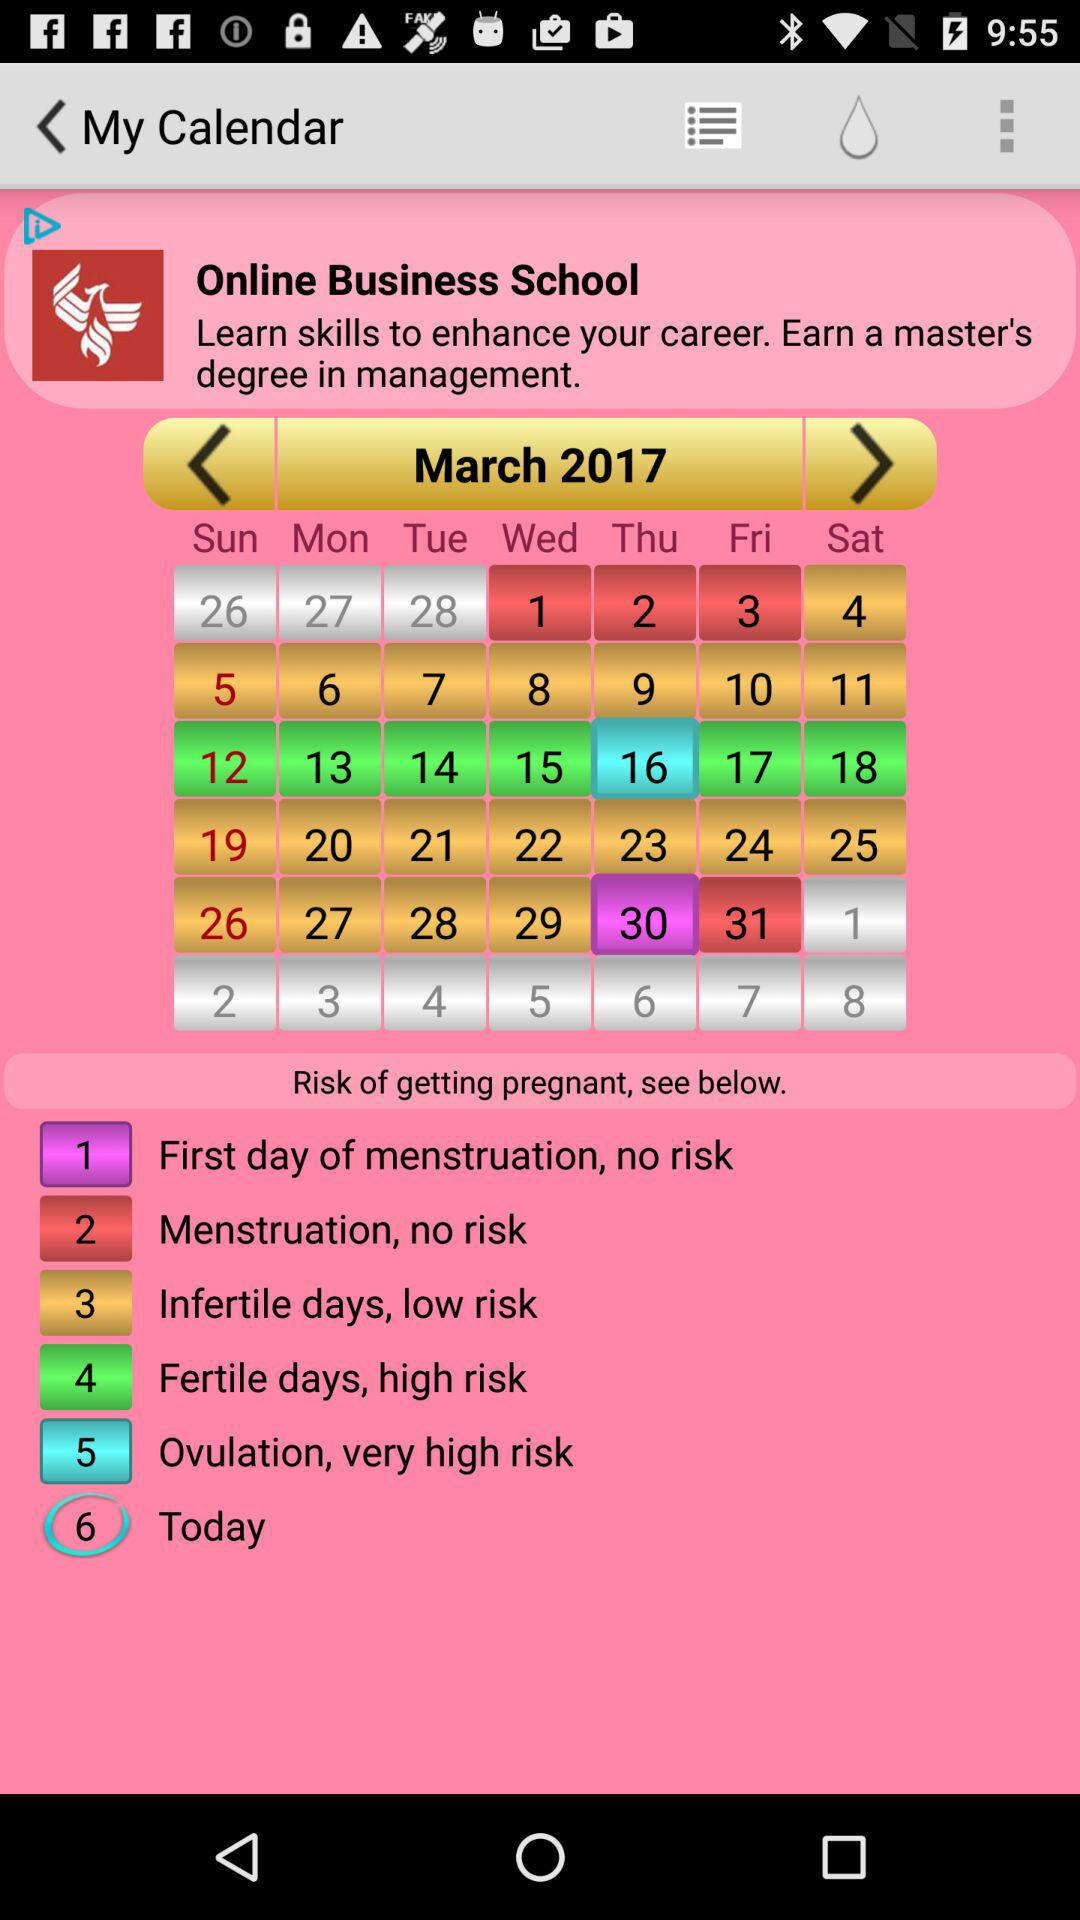What is the menstruation date? The menstruation dates are from March 1, 2017 to March 3, 2017 and March 31, 2017. 